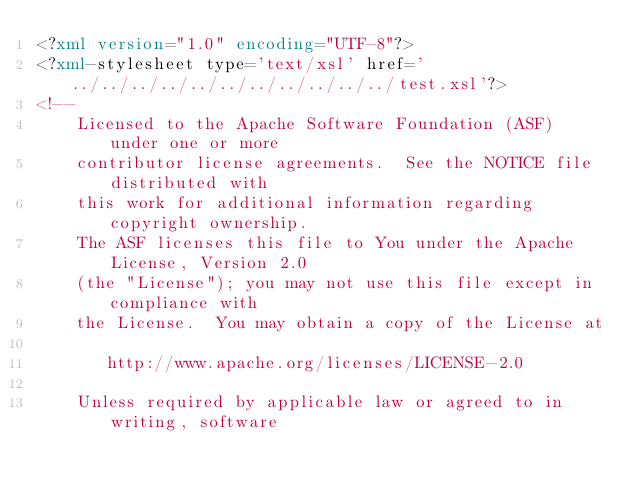<code> <loc_0><loc_0><loc_500><loc_500><_XML_><?xml version="1.0" encoding="UTF-8"?>
<?xml-stylesheet type='text/xsl' href='../../../../../../../../../../../test.xsl'?>
<!--
    Licensed to the Apache Software Foundation (ASF) under one or more
    contributor license agreements.  See the NOTICE file distributed with
    this work for additional information regarding copyright ownership.
    The ASF licenses this file to You under the Apache License, Version 2.0
    (the "License"); you may not use this file except in compliance with
    the License.  You may obtain a copy of the License at
  
       http://www.apache.org/licenses/LICENSE-2.0
  
    Unless required by applicable law or agreed to in writing, software</code> 